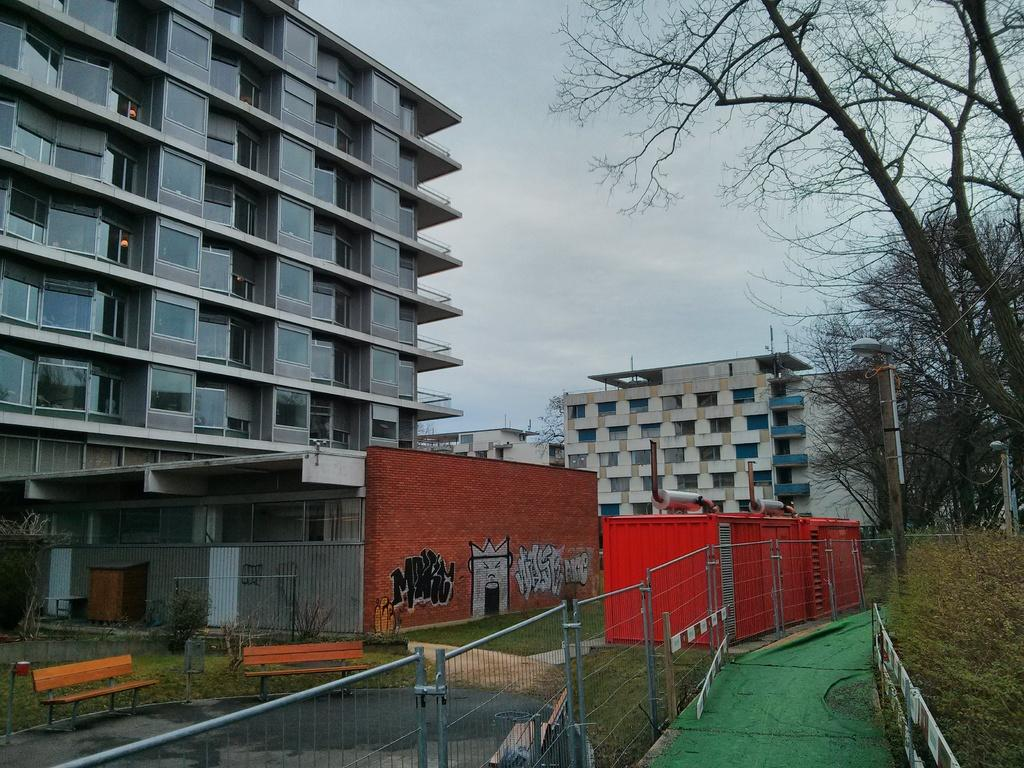What type of structures can be seen in the image? There are buildings in the image. What type of vegetation is present in the image? There are trees in the image. What type of vertical structures can be seen in the image? There are poles in the image. What type of barrier can be seen in the image? There is a fence in the image. What type of seating is present in the image? There are benches in the image. What type of support structures can be seen in the image? There are railings in the image. What type of container is present in the image? There is a box in the image. What is visible at the top of the image? The sky is visible at the top of the image. How many ants are crawling on the buildings in the image? There are no ants present in the image; it features buildings, trees, poles, a fence, benches, railings, a box, and a visible sky. What type of test is being conducted on the benches in the image? There is no test being conducted on the benches in the image; they are simply seating structures. 